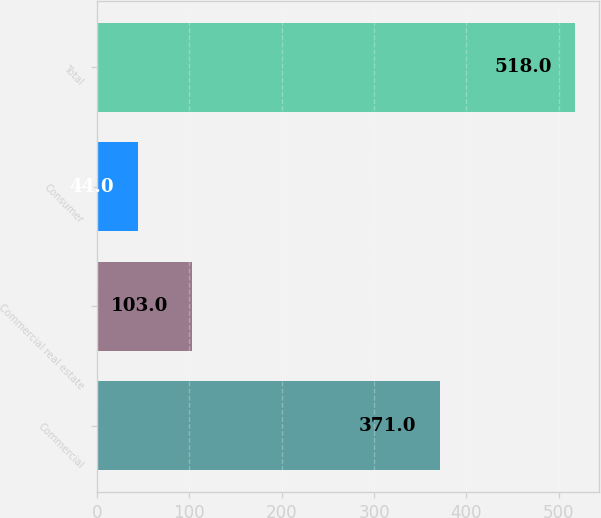Convert chart to OTSL. <chart><loc_0><loc_0><loc_500><loc_500><bar_chart><fcel>Commercial<fcel>Commercial real estate<fcel>Consumer<fcel>Total<nl><fcel>371<fcel>103<fcel>44<fcel>518<nl></chart> 